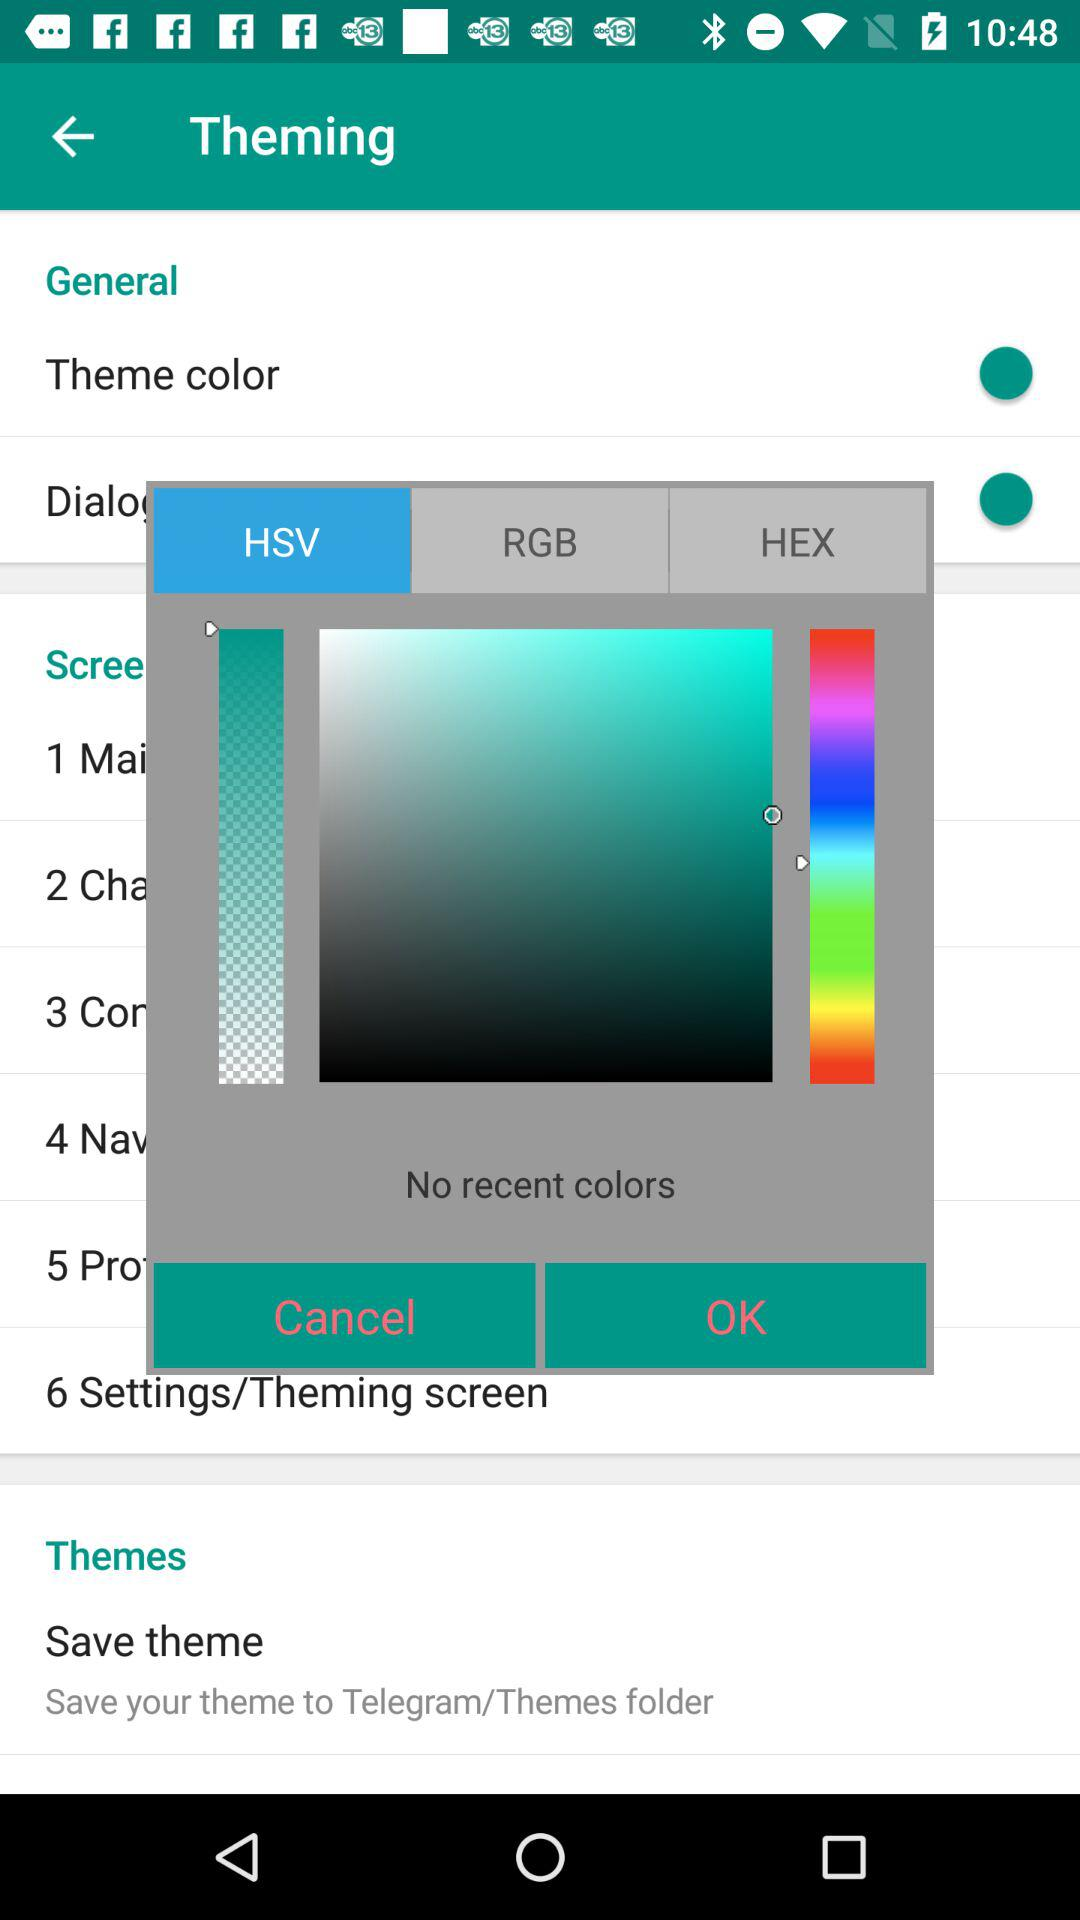Which tab is selected? The selected tab is "HSV". 